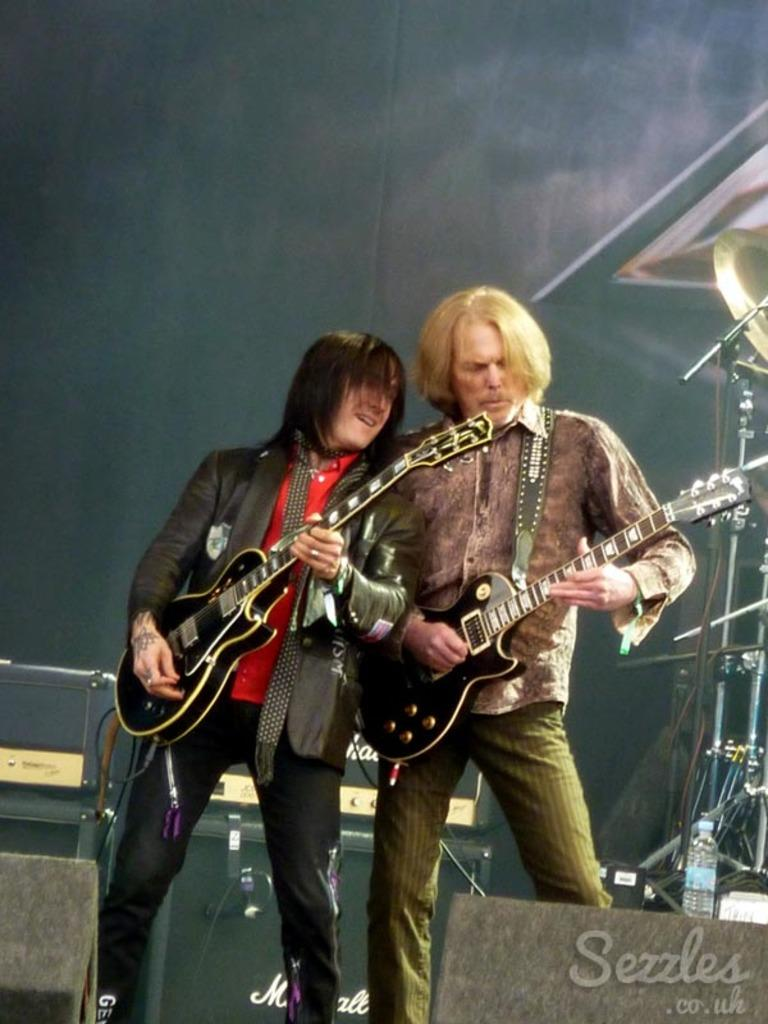How many people are in the image? There are two persons in the image. What are the people in the image doing? Both persons are playing the guitar. What is the facial expression of the people in the image? Both persons are smiling. What type of agreement did the girls reach in the image? There are no girls present in the image, and no agreement is mentioned or depicted. 